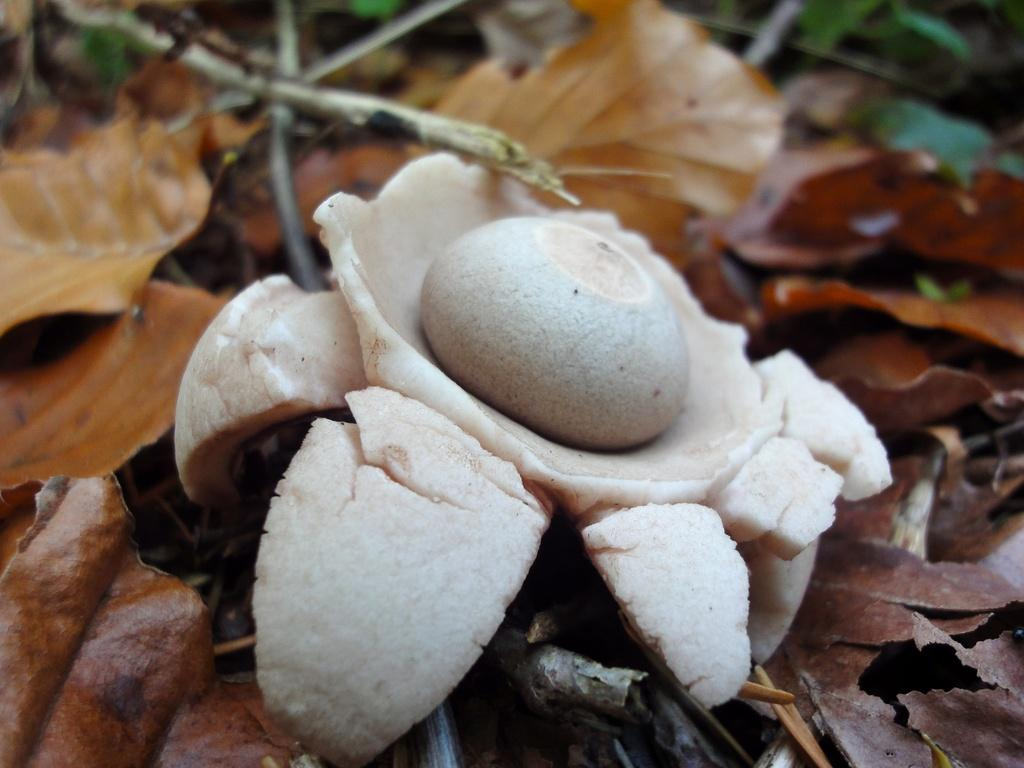What color is the object in the image? The object in the image is white. What is the object placed on? The object is on dried leaves. How does the object provide support to the roots in the image? The image does not show any roots, and the object is not providing support to any roots. 